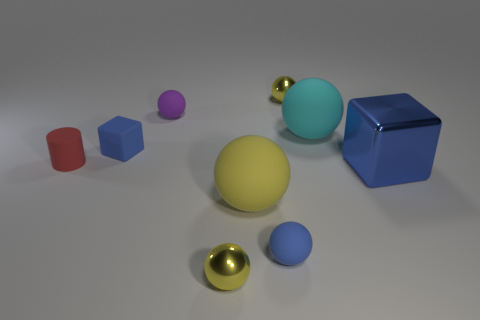Is the small cylinder the same color as the big block?
Ensure brevity in your answer.  No. What number of red rubber cylinders are to the left of the shiny ball left of the shiny object behind the blue shiny thing?
Your answer should be very brief. 1. What size is the matte cube?
Make the answer very short. Small. What is the material of the cylinder that is the same size as the purple rubber object?
Offer a very short reply. Rubber. How many spheres are in front of the purple ball?
Your answer should be compact. 4. Do the tiny yellow thing that is behind the big metal cube and the large ball behind the blue shiny object have the same material?
Offer a terse response. No. There is a tiny yellow thing that is to the left of the tiny metal sphere that is behind the small blue object that is in front of the red rubber object; what is its shape?
Offer a terse response. Sphere. The big metal object is what shape?
Your answer should be very brief. Cube. The purple thing that is the same size as the red thing is what shape?
Give a very brief answer. Sphere. What number of other objects are there of the same color as the tiny rubber cube?
Provide a short and direct response. 2. 